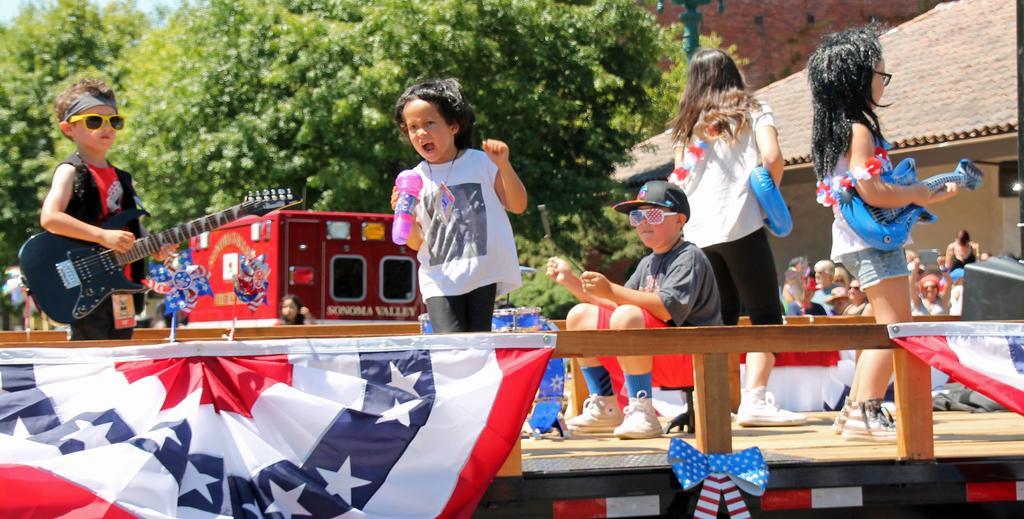Could you give a brief overview of what you see in this image? This is a picture taken in the outdoors. It is sunny. There are group of kids are playing music on stage. The boy in black jacket was holding a guitar and the girl in white dress also holding a guitar. The stage is decorated with flags. Behind the kids there are group of people standing, vehicle, house, tree and a pole. 